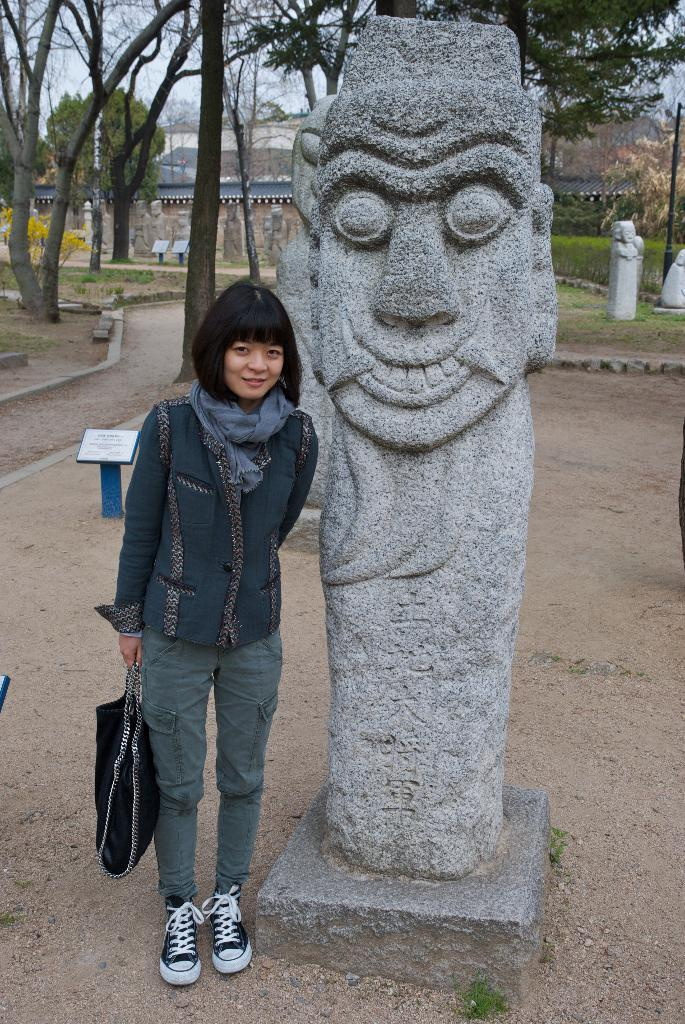What is the person in the image doing? The person is standing on the ground in the image. What is located beside the person in the image? The person is standing beside a statue. What can be seen in the background of the image? There is sky, trees, buildings, poles, and plants visible in the background of the image. What type of education is being taught by the statue in the image? There is no statue teaching education in the image. The statue is simply a statue, and it is not engaged in any educational activities. 